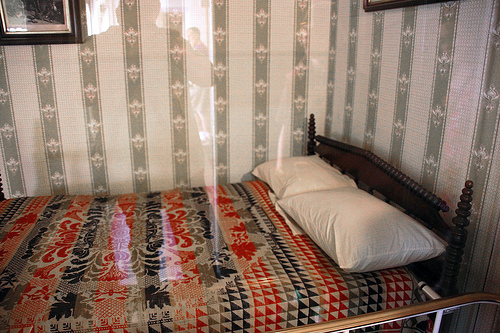What style or era does the room's decor suggest? The room's decor suggests a vintage or retro style, possibly from the early to mid-20th century. The patterned wallpaper, traditional wooden bed frame, and the ornate quilt all contribute to a historical and classic ambiance. 